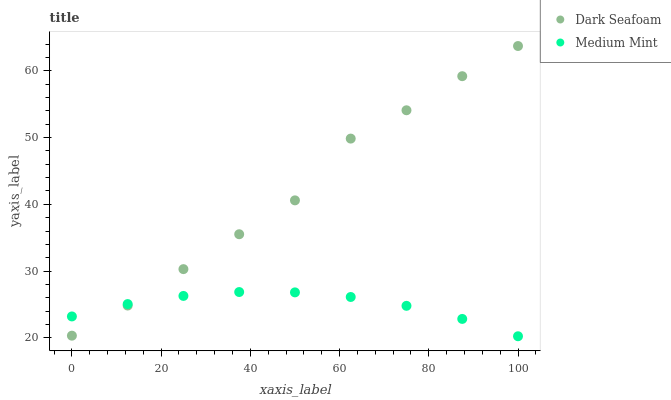Does Medium Mint have the minimum area under the curve?
Answer yes or no. Yes. Does Dark Seafoam have the maximum area under the curve?
Answer yes or no. Yes. Does Dark Seafoam have the minimum area under the curve?
Answer yes or no. No. Is Medium Mint the smoothest?
Answer yes or no. Yes. Is Dark Seafoam the roughest?
Answer yes or no. Yes. Is Dark Seafoam the smoothest?
Answer yes or no. No. Does Medium Mint have the lowest value?
Answer yes or no. Yes. Does Dark Seafoam have the lowest value?
Answer yes or no. No. Does Dark Seafoam have the highest value?
Answer yes or no. Yes. Does Medium Mint intersect Dark Seafoam?
Answer yes or no. Yes. Is Medium Mint less than Dark Seafoam?
Answer yes or no. No. Is Medium Mint greater than Dark Seafoam?
Answer yes or no. No. 